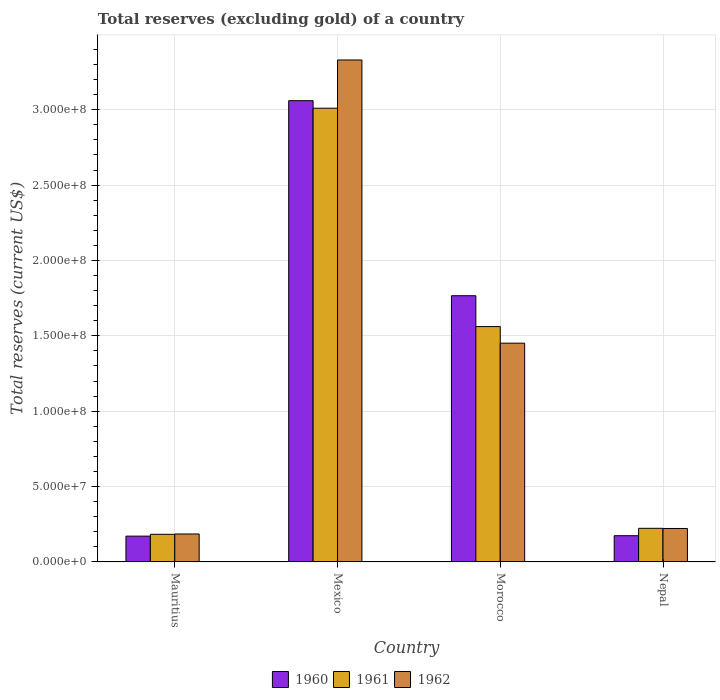Are the number of bars per tick equal to the number of legend labels?
Give a very brief answer. Yes. How many bars are there on the 1st tick from the left?
Your answer should be compact. 3. How many bars are there on the 2nd tick from the right?
Provide a succinct answer. 3. What is the label of the 2nd group of bars from the left?
Give a very brief answer. Mexico. In how many cases, is the number of bars for a given country not equal to the number of legend labels?
Your answer should be compact. 0. What is the total reserves (excluding gold) in 1962 in Nepal?
Ensure brevity in your answer.  2.22e+07. Across all countries, what is the maximum total reserves (excluding gold) in 1962?
Ensure brevity in your answer.  3.33e+08. Across all countries, what is the minimum total reserves (excluding gold) in 1960?
Give a very brief answer. 1.71e+07. In which country was the total reserves (excluding gold) in 1962 maximum?
Provide a succinct answer. Mexico. In which country was the total reserves (excluding gold) in 1961 minimum?
Give a very brief answer. Mauritius. What is the total total reserves (excluding gold) in 1962 in the graph?
Provide a short and direct response. 5.19e+08. What is the difference between the total reserves (excluding gold) in 1960 in Morocco and that in Nepal?
Your answer should be very brief. 1.59e+08. What is the difference between the total reserves (excluding gold) in 1961 in Mexico and the total reserves (excluding gold) in 1960 in Morocco?
Your response must be concise. 1.24e+08. What is the average total reserves (excluding gold) in 1962 per country?
Your response must be concise. 1.30e+08. What is the difference between the total reserves (excluding gold) of/in 1961 and total reserves (excluding gold) of/in 1960 in Mauritius?
Your response must be concise. 1.22e+06. In how many countries, is the total reserves (excluding gold) in 1961 greater than 160000000 US$?
Offer a terse response. 1. What is the ratio of the total reserves (excluding gold) in 1960 in Mexico to that in Morocco?
Provide a short and direct response. 1.73. Is the difference between the total reserves (excluding gold) in 1961 in Mexico and Morocco greater than the difference between the total reserves (excluding gold) in 1960 in Mexico and Morocco?
Give a very brief answer. Yes. What is the difference between the highest and the second highest total reserves (excluding gold) in 1961?
Keep it short and to the point. 2.79e+08. What is the difference between the highest and the lowest total reserves (excluding gold) in 1961?
Your answer should be very brief. 2.83e+08. What does the 1st bar from the left in Nepal represents?
Give a very brief answer. 1960. What does the 2nd bar from the right in Mauritius represents?
Give a very brief answer. 1961. How many bars are there?
Your answer should be very brief. 12. Are all the bars in the graph horizontal?
Provide a succinct answer. No. How many countries are there in the graph?
Your answer should be very brief. 4. Are the values on the major ticks of Y-axis written in scientific E-notation?
Provide a succinct answer. Yes. Does the graph contain grids?
Provide a succinct answer. Yes. How many legend labels are there?
Keep it short and to the point. 3. What is the title of the graph?
Give a very brief answer. Total reserves (excluding gold) of a country. What is the label or title of the Y-axis?
Keep it short and to the point. Total reserves (current US$). What is the Total reserves (current US$) in 1960 in Mauritius?
Make the answer very short. 1.71e+07. What is the Total reserves (current US$) of 1961 in Mauritius?
Make the answer very short. 1.83e+07. What is the Total reserves (current US$) in 1962 in Mauritius?
Your answer should be compact. 1.86e+07. What is the Total reserves (current US$) in 1960 in Mexico?
Offer a very short reply. 3.06e+08. What is the Total reserves (current US$) in 1961 in Mexico?
Your answer should be compact. 3.01e+08. What is the Total reserves (current US$) of 1962 in Mexico?
Your response must be concise. 3.33e+08. What is the Total reserves (current US$) of 1960 in Morocco?
Your answer should be compact. 1.77e+08. What is the Total reserves (current US$) of 1961 in Morocco?
Offer a terse response. 1.56e+08. What is the Total reserves (current US$) of 1962 in Morocco?
Offer a terse response. 1.45e+08. What is the Total reserves (current US$) of 1960 in Nepal?
Make the answer very short. 1.74e+07. What is the Total reserves (current US$) in 1961 in Nepal?
Provide a succinct answer. 2.23e+07. What is the Total reserves (current US$) of 1962 in Nepal?
Your response must be concise. 2.22e+07. Across all countries, what is the maximum Total reserves (current US$) in 1960?
Provide a succinct answer. 3.06e+08. Across all countries, what is the maximum Total reserves (current US$) in 1961?
Your answer should be compact. 3.01e+08. Across all countries, what is the maximum Total reserves (current US$) of 1962?
Your answer should be compact. 3.33e+08. Across all countries, what is the minimum Total reserves (current US$) of 1960?
Keep it short and to the point. 1.71e+07. Across all countries, what is the minimum Total reserves (current US$) in 1961?
Your answer should be very brief. 1.83e+07. Across all countries, what is the minimum Total reserves (current US$) in 1962?
Provide a succinct answer. 1.86e+07. What is the total Total reserves (current US$) of 1960 in the graph?
Make the answer very short. 5.17e+08. What is the total Total reserves (current US$) of 1961 in the graph?
Give a very brief answer. 4.98e+08. What is the total Total reserves (current US$) in 1962 in the graph?
Your answer should be compact. 5.19e+08. What is the difference between the Total reserves (current US$) in 1960 in Mauritius and that in Mexico?
Your response must be concise. -2.89e+08. What is the difference between the Total reserves (current US$) in 1961 in Mauritius and that in Mexico?
Ensure brevity in your answer.  -2.83e+08. What is the difference between the Total reserves (current US$) in 1962 in Mauritius and that in Mexico?
Your response must be concise. -3.14e+08. What is the difference between the Total reserves (current US$) of 1960 in Mauritius and that in Morocco?
Provide a short and direct response. -1.59e+08. What is the difference between the Total reserves (current US$) of 1961 in Mauritius and that in Morocco?
Offer a very short reply. -1.38e+08. What is the difference between the Total reserves (current US$) of 1962 in Mauritius and that in Morocco?
Give a very brief answer. -1.27e+08. What is the difference between the Total reserves (current US$) in 1960 in Mauritius and that in Nepal?
Make the answer very short. -2.80e+05. What is the difference between the Total reserves (current US$) in 1961 in Mauritius and that in Nepal?
Ensure brevity in your answer.  -3.96e+06. What is the difference between the Total reserves (current US$) of 1962 in Mauritius and that in Nepal?
Your response must be concise. -3.65e+06. What is the difference between the Total reserves (current US$) of 1960 in Mexico and that in Morocco?
Give a very brief answer. 1.29e+08. What is the difference between the Total reserves (current US$) of 1961 in Mexico and that in Morocco?
Make the answer very short. 1.45e+08. What is the difference between the Total reserves (current US$) in 1962 in Mexico and that in Morocco?
Give a very brief answer. 1.88e+08. What is the difference between the Total reserves (current US$) of 1960 in Mexico and that in Nepal?
Your answer should be very brief. 2.89e+08. What is the difference between the Total reserves (current US$) in 1961 in Mexico and that in Nepal?
Your answer should be compact. 2.79e+08. What is the difference between the Total reserves (current US$) of 1962 in Mexico and that in Nepal?
Your answer should be very brief. 3.11e+08. What is the difference between the Total reserves (current US$) in 1960 in Morocco and that in Nepal?
Make the answer very short. 1.59e+08. What is the difference between the Total reserves (current US$) in 1961 in Morocco and that in Nepal?
Provide a short and direct response. 1.34e+08. What is the difference between the Total reserves (current US$) of 1962 in Morocco and that in Nepal?
Your answer should be compact. 1.23e+08. What is the difference between the Total reserves (current US$) in 1960 in Mauritius and the Total reserves (current US$) in 1961 in Mexico?
Give a very brief answer. -2.84e+08. What is the difference between the Total reserves (current US$) in 1960 in Mauritius and the Total reserves (current US$) in 1962 in Mexico?
Your response must be concise. -3.16e+08. What is the difference between the Total reserves (current US$) of 1961 in Mauritius and the Total reserves (current US$) of 1962 in Mexico?
Offer a very short reply. -3.15e+08. What is the difference between the Total reserves (current US$) in 1960 in Mauritius and the Total reserves (current US$) in 1961 in Morocco?
Provide a short and direct response. -1.39e+08. What is the difference between the Total reserves (current US$) in 1960 in Mauritius and the Total reserves (current US$) in 1962 in Morocco?
Keep it short and to the point. -1.28e+08. What is the difference between the Total reserves (current US$) in 1961 in Mauritius and the Total reserves (current US$) in 1962 in Morocco?
Offer a terse response. -1.27e+08. What is the difference between the Total reserves (current US$) of 1960 in Mauritius and the Total reserves (current US$) of 1961 in Nepal?
Keep it short and to the point. -5.18e+06. What is the difference between the Total reserves (current US$) of 1960 in Mauritius and the Total reserves (current US$) of 1962 in Nepal?
Make the answer very short. -5.08e+06. What is the difference between the Total reserves (current US$) of 1961 in Mauritius and the Total reserves (current US$) of 1962 in Nepal?
Offer a terse response. -3.86e+06. What is the difference between the Total reserves (current US$) in 1960 in Mexico and the Total reserves (current US$) in 1961 in Morocco?
Your answer should be compact. 1.50e+08. What is the difference between the Total reserves (current US$) in 1960 in Mexico and the Total reserves (current US$) in 1962 in Morocco?
Your response must be concise. 1.61e+08. What is the difference between the Total reserves (current US$) in 1961 in Mexico and the Total reserves (current US$) in 1962 in Morocco?
Make the answer very short. 1.56e+08. What is the difference between the Total reserves (current US$) of 1960 in Mexico and the Total reserves (current US$) of 1961 in Nepal?
Your answer should be compact. 2.84e+08. What is the difference between the Total reserves (current US$) of 1960 in Mexico and the Total reserves (current US$) of 1962 in Nepal?
Offer a very short reply. 2.84e+08. What is the difference between the Total reserves (current US$) in 1961 in Mexico and the Total reserves (current US$) in 1962 in Nepal?
Your answer should be very brief. 2.79e+08. What is the difference between the Total reserves (current US$) in 1960 in Morocco and the Total reserves (current US$) in 1961 in Nepal?
Your response must be concise. 1.54e+08. What is the difference between the Total reserves (current US$) of 1960 in Morocco and the Total reserves (current US$) of 1962 in Nepal?
Provide a short and direct response. 1.54e+08. What is the difference between the Total reserves (current US$) of 1961 in Morocco and the Total reserves (current US$) of 1962 in Nepal?
Offer a very short reply. 1.34e+08. What is the average Total reserves (current US$) in 1960 per country?
Provide a succinct answer. 1.29e+08. What is the average Total reserves (current US$) of 1961 per country?
Offer a terse response. 1.24e+08. What is the average Total reserves (current US$) in 1962 per country?
Provide a short and direct response. 1.30e+08. What is the difference between the Total reserves (current US$) in 1960 and Total reserves (current US$) in 1961 in Mauritius?
Give a very brief answer. -1.22e+06. What is the difference between the Total reserves (current US$) in 1960 and Total reserves (current US$) in 1962 in Mauritius?
Provide a short and direct response. -1.43e+06. What is the difference between the Total reserves (current US$) in 1960 and Total reserves (current US$) in 1961 in Mexico?
Give a very brief answer. 5.00e+06. What is the difference between the Total reserves (current US$) in 1960 and Total reserves (current US$) in 1962 in Mexico?
Your answer should be compact. -2.70e+07. What is the difference between the Total reserves (current US$) of 1961 and Total reserves (current US$) of 1962 in Mexico?
Ensure brevity in your answer.  -3.20e+07. What is the difference between the Total reserves (current US$) in 1960 and Total reserves (current US$) in 1961 in Morocco?
Provide a short and direct response. 2.05e+07. What is the difference between the Total reserves (current US$) of 1960 and Total reserves (current US$) of 1962 in Morocco?
Provide a succinct answer. 3.15e+07. What is the difference between the Total reserves (current US$) in 1961 and Total reserves (current US$) in 1962 in Morocco?
Make the answer very short. 1.10e+07. What is the difference between the Total reserves (current US$) of 1960 and Total reserves (current US$) of 1961 in Nepal?
Your answer should be compact. -4.90e+06. What is the difference between the Total reserves (current US$) of 1960 and Total reserves (current US$) of 1962 in Nepal?
Make the answer very short. -4.80e+06. What is the ratio of the Total reserves (current US$) of 1960 in Mauritius to that in Mexico?
Give a very brief answer. 0.06. What is the ratio of the Total reserves (current US$) of 1961 in Mauritius to that in Mexico?
Give a very brief answer. 0.06. What is the ratio of the Total reserves (current US$) of 1962 in Mauritius to that in Mexico?
Your answer should be very brief. 0.06. What is the ratio of the Total reserves (current US$) of 1960 in Mauritius to that in Morocco?
Provide a succinct answer. 0.1. What is the ratio of the Total reserves (current US$) in 1961 in Mauritius to that in Morocco?
Your answer should be very brief. 0.12. What is the ratio of the Total reserves (current US$) of 1962 in Mauritius to that in Morocco?
Provide a short and direct response. 0.13. What is the ratio of the Total reserves (current US$) in 1960 in Mauritius to that in Nepal?
Offer a very short reply. 0.98. What is the ratio of the Total reserves (current US$) of 1961 in Mauritius to that in Nepal?
Offer a terse response. 0.82. What is the ratio of the Total reserves (current US$) of 1962 in Mauritius to that in Nepal?
Make the answer very short. 0.84. What is the ratio of the Total reserves (current US$) of 1960 in Mexico to that in Morocco?
Your answer should be compact. 1.73. What is the ratio of the Total reserves (current US$) of 1961 in Mexico to that in Morocco?
Give a very brief answer. 1.93. What is the ratio of the Total reserves (current US$) in 1962 in Mexico to that in Morocco?
Offer a very short reply. 2.29. What is the ratio of the Total reserves (current US$) of 1960 in Mexico to that in Nepal?
Offer a very short reply. 17.59. What is the ratio of the Total reserves (current US$) in 1961 in Mexico to that in Nepal?
Ensure brevity in your answer.  13.5. What is the ratio of the Total reserves (current US$) of 1960 in Morocco to that in Nepal?
Offer a very short reply. 10.15. What is the ratio of the Total reserves (current US$) in 1961 in Morocco to that in Nepal?
Make the answer very short. 7. What is the ratio of the Total reserves (current US$) of 1962 in Morocco to that in Nepal?
Your response must be concise. 6.54. What is the difference between the highest and the second highest Total reserves (current US$) in 1960?
Offer a terse response. 1.29e+08. What is the difference between the highest and the second highest Total reserves (current US$) of 1961?
Your answer should be very brief. 1.45e+08. What is the difference between the highest and the second highest Total reserves (current US$) of 1962?
Your response must be concise. 1.88e+08. What is the difference between the highest and the lowest Total reserves (current US$) in 1960?
Your answer should be very brief. 2.89e+08. What is the difference between the highest and the lowest Total reserves (current US$) of 1961?
Give a very brief answer. 2.83e+08. What is the difference between the highest and the lowest Total reserves (current US$) of 1962?
Keep it short and to the point. 3.14e+08. 